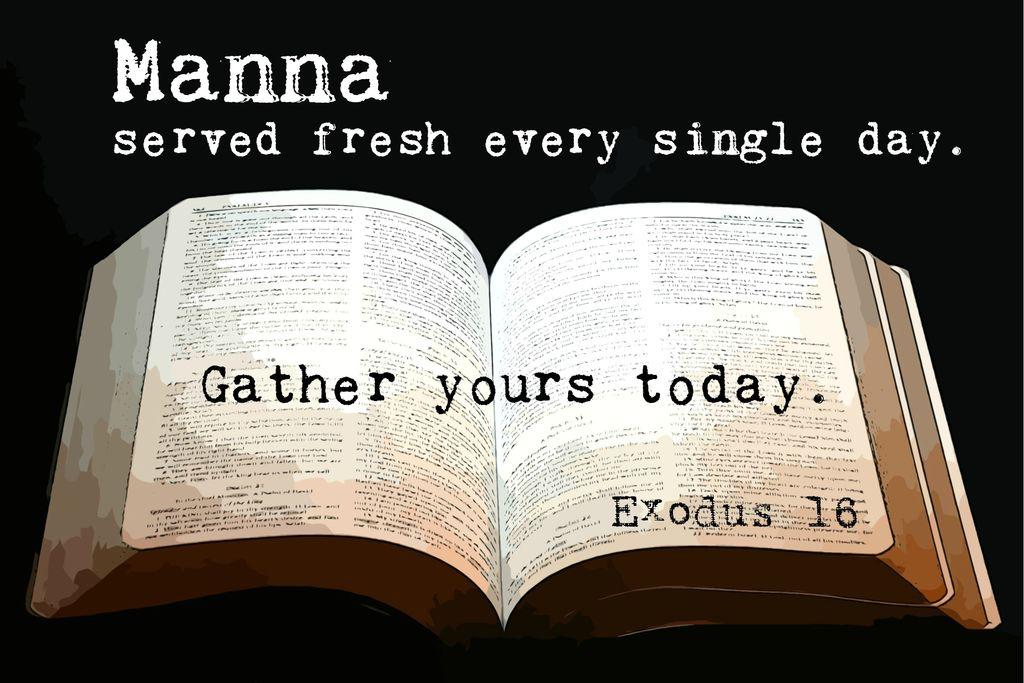<image>
Write a terse but informative summary of the picture. An open bible has the caption Gather yours today. 